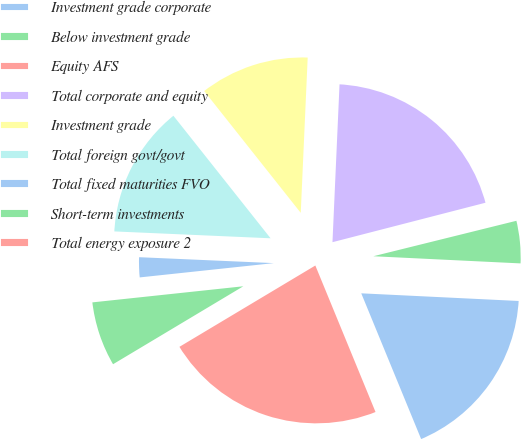Convert chart to OTSL. <chart><loc_0><loc_0><loc_500><loc_500><pie_chart><fcel>Investment grade corporate<fcel>Below investment grade<fcel>Equity AFS<fcel>Total corporate and equity<fcel>Investment grade<fcel>Total foreign govt/govt<fcel>Total fixed maturities FVO<fcel>Short-term investments<fcel>Total energy exposure 2<nl><fcel>18.02%<fcel>4.64%<fcel>0.15%<fcel>20.27%<fcel>11.38%<fcel>13.63%<fcel>2.39%<fcel>6.89%<fcel>22.62%<nl></chart> 